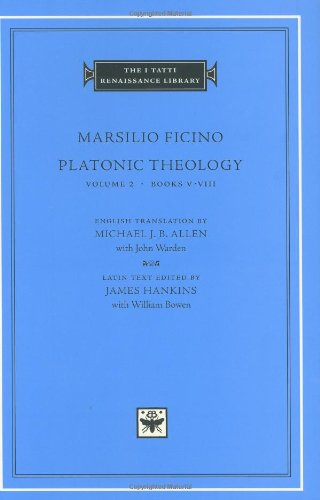How would this book influence the thinking of its contemporary readers? This book, through its rigorous examination of Platonic thought, would have significantly influenced contemporary readers by bridging the gap between classical philosophy and Renaissance humanism, thereby enriching their intellectual and spiritual outlook. 